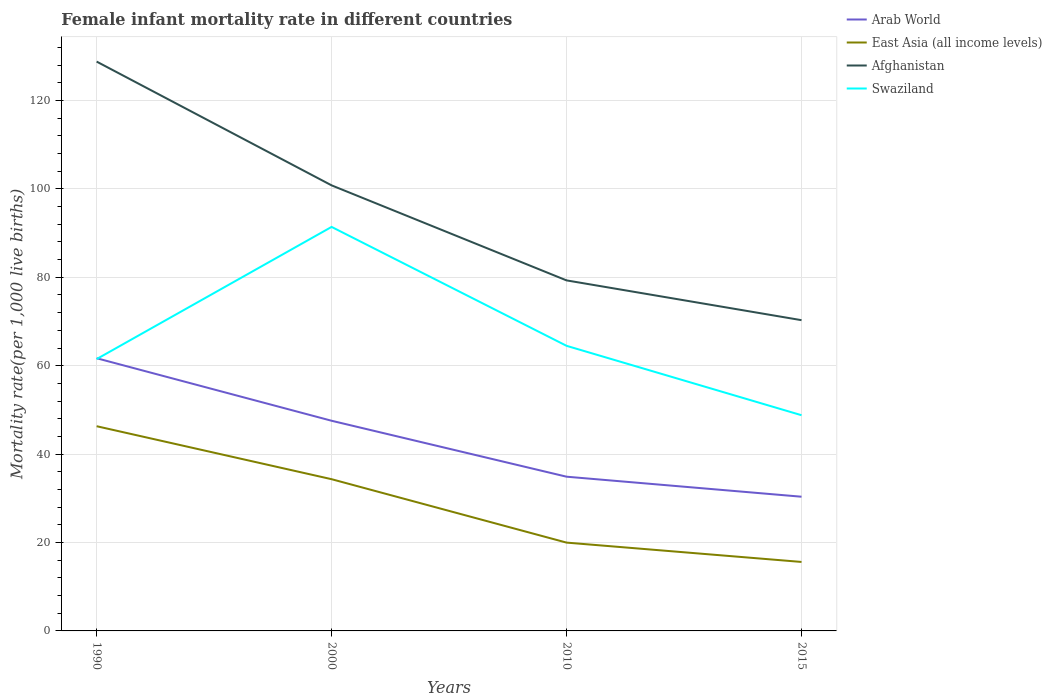How many different coloured lines are there?
Provide a short and direct response. 4. Is the number of lines equal to the number of legend labels?
Give a very brief answer. Yes. Across all years, what is the maximum female infant mortality rate in East Asia (all income levels)?
Give a very brief answer. 15.6. In which year was the female infant mortality rate in Afghanistan maximum?
Keep it short and to the point. 2015. What is the total female infant mortality rate in East Asia (all income levels) in the graph?
Your answer should be compact. 14.35. What is the difference between the highest and the second highest female infant mortality rate in East Asia (all income levels)?
Offer a very short reply. 30.71. What is the difference between two consecutive major ticks on the Y-axis?
Make the answer very short. 20. Are the values on the major ticks of Y-axis written in scientific E-notation?
Provide a succinct answer. No. Does the graph contain any zero values?
Your response must be concise. No. How many legend labels are there?
Provide a short and direct response. 4. What is the title of the graph?
Make the answer very short. Female infant mortality rate in different countries. What is the label or title of the X-axis?
Provide a succinct answer. Years. What is the label or title of the Y-axis?
Offer a very short reply. Mortality rate(per 1,0 live births). What is the Mortality rate(per 1,000 live births) of Arab World in 1990?
Ensure brevity in your answer.  61.69. What is the Mortality rate(per 1,000 live births) of East Asia (all income levels) in 1990?
Make the answer very short. 46.31. What is the Mortality rate(per 1,000 live births) in Afghanistan in 1990?
Your answer should be compact. 128.8. What is the Mortality rate(per 1,000 live births) in Swaziland in 1990?
Provide a short and direct response. 61.5. What is the Mortality rate(per 1,000 live births) of Arab World in 2000?
Provide a short and direct response. 47.55. What is the Mortality rate(per 1,000 live births) of East Asia (all income levels) in 2000?
Your answer should be compact. 34.33. What is the Mortality rate(per 1,000 live births) of Afghanistan in 2000?
Give a very brief answer. 100.8. What is the Mortality rate(per 1,000 live births) in Swaziland in 2000?
Ensure brevity in your answer.  91.4. What is the Mortality rate(per 1,000 live births) in Arab World in 2010?
Offer a terse response. 34.89. What is the Mortality rate(per 1,000 live births) in East Asia (all income levels) in 2010?
Provide a succinct answer. 19.98. What is the Mortality rate(per 1,000 live births) of Afghanistan in 2010?
Your response must be concise. 79.3. What is the Mortality rate(per 1,000 live births) of Swaziland in 2010?
Offer a terse response. 64.5. What is the Mortality rate(per 1,000 live births) of Arab World in 2015?
Offer a terse response. 30.36. What is the Mortality rate(per 1,000 live births) of East Asia (all income levels) in 2015?
Your answer should be compact. 15.6. What is the Mortality rate(per 1,000 live births) of Afghanistan in 2015?
Your answer should be compact. 70.3. What is the Mortality rate(per 1,000 live births) in Swaziland in 2015?
Offer a very short reply. 48.8. Across all years, what is the maximum Mortality rate(per 1,000 live births) of Arab World?
Ensure brevity in your answer.  61.69. Across all years, what is the maximum Mortality rate(per 1,000 live births) in East Asia (all income levels)?
Ensure brevity in your answer.  46.31. Across all years, what is the maximum Mortality rate(per 1,000 live births) in Afghanistan?
Give a very brief answer. 128.8. Across all years, what is the maximum Mortality rate(per 1,000 live births) of Swaziland?
Provide a short and direct response. 91.4. Across all years, what is the minimum Mortality rate(per 1,000 live births) of Arab World?
Offer a terse response. 30.36. Across all years, what is the minimum Mortality rate(per 1,000 live births) in East Asia (all income levels)?
Keep it short and to the point. 15.6. Across all years, what is the minimum Mortality rate(per 1,000 live births) of Afghanistan?
Offer a very short reply. 70.3. Across all years, what is the minimum Mortality rate(per 1,000 live births) in Swaziland?
Give a very brief answer. 48.8. What is the total Mortality rate(per 1,000 live births) of Arab World in the graph?
Provide a short and direct response. 174.49. What is the total Mortality rate(per 1,000 live births) of East Asia (all income levels) in the graph?
Your answer should be compact. 116.22. What is the total Mortality rate(per 1,000 live births) in Afghanistan in the graph?
Offer a terse response. 379.2. What is the total Mortality rate(per 1,000 live births) in Swaziland in the graph?
Your answer should be compact. 266.2. What is the difference between the Mortality rate(per 1,000 live births) of Arab World in 1990 and that in 2000?
Your answer should be very brief. 14.15. What is the difference between the Mortality rate(per 1,000 live births) of East Asia (all income levels) in 1990 and that in 2000?
Your response must be concise. 11.99. What is the difference between the Mortality rate(per 1,000 live births) in Afghanistan in 1990 and that in 2000?
Provide a succinct answer. 28. What is the difference between the Mortality rate(per 1,000 live births) of Swaziland in 1990 and that in 2000?
Give a very brief answer. -29.9. What is the difference between the Mortality rate(per 1,000 live births) in Arab World in 1990 and that in 2010?
Provide a short and direct response. 26.8. What is the difference between the Mortality rate(per 1,000 live births) of East Asia (all income levels) in 1990 and that in 2010?
Make the answer very short. 26.33. What is the difference between the Mortality rate(per 1,000 live births) of Afghanistan in 1990 and that in 2010?
Keep it short and to the point. 49.5. What is the difference between the Mortality rate(per 1,000 live births) of Arab World in 1990 and that in 2015?
Provide a short and direct response. 31.33. What is the difference between the Mortality rate(per 1,000 live births) of East Asia (all income levels) in 1990 and that in 2015?
Provide a succinct answer. 30.71. What is the difference between the Mortality rate(per 1,000 live births) of Afghanistan in 1990 and that in 2015?
Your answer should be very brief. 58.5. What is the difference between the Mortality rate(per 1,000 live births) in Arab World in 2000 and that in 2010?
Give a very brief answer. 12.65. What is the difference between the Mortality rate(per 1,000 live births) of East Asia (all income levels) in 2000 and that in 2010?
Make the answer very short. 14.35. What is the difference between the Mortality rate(per 1,000 live births) in Swaziland in 2000 and that in 2010?
Keep it short and to the point. 26.9. What is the difference between the Mortality rate(per 1,000 live births) of Arab World in 2000 and that in 2015?
Make the answer very short. 17.18. What is the difference between the Mortality rate(per 1,000 live births) of East Asia (all income levels) in 2000 and that in 2015?
Your answer should be compact. 18.72. What is the difference between the Mortality rate(per 1,000 live births) in Afghanistan in 2000 and that in 2015?
Make the answer very short. 30.5. What is the difference between the Mortality rate(per 1,000 live births) in Swaziland in 2000 and that in 2015?
Your response must be concise. 42.6. What is the difference between the Mortality rate(per 1,000 live births) of Arab World in 2010 and that in 2015?
Give a very brief answer. 4.53. What is the difference between the Mortality rate(per 1,000 live births) in East Asia (all income levels) in 2010 and that in 2015?
Provide a short and direct response. 4.37. What is the difference between the Mortality rate(per 1,000 live births) of Arab World in 1990 and the Mortality rate(per 1,000 live births) of East Asia (all income levels) in 2000?
Make the answer very short. 27.37. What is the difference between the Mortality rate(per 1,000 live births) of Arab World in 1990 and the Mortality rate(per 1,000 live births) of Afghanistan in 2000?
Provide a short and direct response. -39.11. What is the difference between the Mortality rate(per 1,000 live births) in Arab World in 1990 and the Mortality rate(per 1,000 live births) in Swaziland in 2000?
Your answer should be compact. -29.71. What is the difference between the Mortality rate(per 1,000 live births) in East Asia (all income levels) in 1990 and the Mortality rate(per 1,000 live births) in Afghanistan in 2000?
Your answer should be very brief. -54.49. What is the difference between the Mortality rate(per 1,000 live births) in East Asia (all income levels) in 1990 and the Mortality rate(per 1,000 live births) in Swaziland in 2000?
Give a very brief answer. -45.09. What is the difference between the Mortality rate(per 1,000 live births) of Afghanistan in 1990 and the Mortality rate(per 1,000 live births) of Swaziland in 2000?
Ensure brevity in your answer.  37.4. What is the difference between the Mortality rate(per 1,000 live births) of Arab World in 1990 and the Mortality rate(per 1,000 live births) of East Asia (all income levels) in 2010?
Keep it short and to the point. 41.71. What is the difference between the Mortality rate(per 1,000 live births) of Arab World in 1990 and the Mortality rate(per 1,000 live births) of Afghanistan in 2010?
Your response must be concise. -17.61. What is the difference between the Mortality rate(per 1,000 live births) in Arab World in 1990 and the Mortality rate(per 1,000 live births) in Swaziland in 2010?
Offer a terse response. -2.81. What is the difference between the Mortality rate(per 1,000 live births) in East Asia (all income levels) in 1990 and the Mortality rate(per 1,000 live births) in Afghanistan in 2010?
Your response must be concise. -32.99. What is the difference between the Mortality rate(per 1,000 live births) of East Asia (all income levels) in 1990 and the Mortality rate(per 1,000 live births) of Swaziland in 2010?
Give a very brief answer. -18.19. What is the difference between the Mortality rate(per 1,000 live births) in Afghanistan in 1990 and the Mortality rate(per 1,000 live births) in Swaziland in 2010?
Your answer should be very brief. 64.3. What is the difference between the Mortality rate(per 1,000 live births) of Arab World in 1990 and the Mortality rate(per 1,000 live births) of East Asia (all income levels) in 2015?
Ensure brevity in your answer.  46.09. What is the difference between the Mortality rate(per 1,000 live births) in Arab World in 1990 and the Mortality rate(per 1,000 live births) in Afghanistan in 2015?
Your answer should be very brief. -8.61. What is the difference between the Mortality rate(per 1,000 live births) of Arab World in 1990 and the Mortality rate(per 1,000 live births) of Swaziland in 2015?
Offer a very short reply. 12.89. What is the difference between the Mortality rate(per 1,000 live births) in East Asia (all income levels) in 1990 and the Mortality rate(per 1,000 live births) in Afghanistan in 2015?
Your answer should be compact. -23.99. What is the difference between the Mortality rate(per 1,000 live births) of East Asia (all income levels) in 1990 and the Mortality rate(per 1,000 live births) of Swaziland in 2015?
Provide a succinct answer. -2.49. What is the difference between the Mortality rate(per 1,000 live births) of Arab World in 2000 and the Mortality rate(per 1,000 live births) of East Asia (all income levels) in 2010?
Give a very brief answer. 27.57. What is the difference between the Mortality rate(per 1,000 live births) in Arab World in 2000 and the Mortality rate(per 1,000 live births) in Afghanistan in 2010?
Keep it short and to the point. -31.75. What is the difference between the Mortality rate(per 1,000 live births) in Arab World in 2000 and the Mortality rate(per 1,000 live births) in Swaziland in 2010?
Give a very brief answer. -16.95. What is the difference between the Mortality rate(per 1,000 live births) in East Asia (all income levels) in 2000 and the Mortality rate(per 1,000 live births) in Afghanistan in 2010?
Provide a succinct answer. -44.97. What is the difference between the Mortality rate(per 1,000 live births) of East Asia (all income levels) in 2000 and the Mortality rate(per 1,000 live births) of Swaziland in 2010?
Your answer should be very brief. -30.17. What is the difference between the Mortality rate(per 1,000 live births) of Afghanistan in 2000 and the Mortality rate(per 1,000 live births) of Swaziland in 2010?
Your answer should be compact. 36.3. What is the difference between the Mortality rate(per 1,000 live births) in Arab World in 2000 and the Mortality rate(per 1,000 live births) in East Asia (all income levels) in 2015?
Your answer should be very brief. 31.94. What is the difference between the Mortality rate(per 1,000 live births) of Arab World in 2000 and the Mortality rate(per 1,000 live births) of Afghanistan in 2015?
Give a very brief answer. -22.75. What is the difference between the Mortality rate(per 1,000 live births) in Arab World in 2000 and the Mortality rate(per 1,000 live births) in Swaziland in 2015?
Provide a short and direct response. -1.25. What is the difference between the Mortality rate(per 1,000 live births) of East Asia (all income levels) in 2000 and the Mortality rate(per 1,000 live births) of Afghanistan in 2015?
Your answer should be very brief. -35.97. What is the difference between the Mortality rate(per 1,000 live births) of East Asia (all income levels) in 2000 and the Mortality rate(per 1,000 live births) of Swaziland in 2015?
Your answer should be very brief. -14.47. What is the difference between the Mortality rate(per 1,000 live births) of Arab World in 2010 and the Mortality rate(per 1,000 live births) of East Asia (all income levels) in 2015?
Give a very brief answer. 19.29. What is the difference between the Mortality rate(per 1,000 live births) in Arab World in 2010 and the Mortality rate(per 1,000 live births) in Afghanistan in 2015?
Your answer should be very brief. -35.41. What is the difference between the Mortality rate(per 1,000 live births) of Arab World in 2010 and the Mortality rate(per 1,000 live births) of Swaziland in 2015?
Offer a terse response. -13.91. What is the difference between the Mortality rate(per 1,000 live births) in East Asia (all income levels) in 2010 and the Mortality rate(per 1,000 live births) in Afghanistan in 2015?
Provide a succinct answer. -50.32. What is the difference between the Mortality rate(per 1,000 live births) in East Asia (all income levels) in 2010 and the Mortality rate(per 1,000 live births) in Swaziland in 2015?
Your response must be concise. -28.82. What is the difference between the Mortality rate(per 1,000 live births) of Afghanistan in 2010 and the Mortality rate(per 1,000 live births) of Swaziland in 2015?
Offer a terse response. 30.5. What is the average Mortality rate(per 1,000 live births) in Arab World per year?
Give a very brief answer. 43.62. What is the average Mortality rate(per 1,000 live births) of East Asia (all income levels) per year?
Your answer should be very brief. 29.06. What is the average Mortality rate(per 1,000 live births) of Afghanistan per year?
Your answer should be compact. 94.8. What is the average Mortality rate(per 1,000 live births) of Swaziland per year?
Make the answer very short. 66.55. In the year 1990, what is the difference between the Mortality rate(per 1,000 live births) of Arab World and Mortality rate(per 1,000 live births) of East Asia (all income levels)?
Offer a terse response. 15.38. In the year 1990, what is the difference between the Mortality rate(per 1,000 live births) in Arab World and Mortality rate(per 1,000 live births) in Afghanistan?
Provide a short and direct response. -67.11. In the year 1990, what is the difference between the Mortality rate(per 1,000 live births) in Arab World and Mortality rate(per 1,000 live births) in Swaziland?
Make the answer very short. 0.19. In the year 1990, what is the difference between the Mortality rate(per 1,000 live births) in East Asia (all income levels) and Mortality rate(per 1,000 live births) in Afghanistan?
Provide a succinct answer. -82.49. In the year 1990, what is the difference between the Mortality rate(per 1,000 live births) of East Asia (all income levels) and Mortality rate(per 1,000 live births) of Swaziland?
Your response must be concise. -15.19. In the year 1990, what is the difference between the Mortality rate(per 1,000 live births) in Afghanistan and Mortality rate(per 1,000 live births) in Swaziland?
Offer a terse response. 67.3. In the year 2000, what is the difference between the Mortality rate(per 1,000 live births) of Arab World and Mortality rate(per 1,000 live births) of East Asia (all income levels)?
Offer a terse response. 13.22. In the year 2000, what is the difference between the Mortality rate(per 1,000 live births) in Arab World and Mortality rate(per 1,000 live births) in Afghanistan?
Give a very brief answer. -53.25. In the year 2000, what is the difference between the Mortality rate(per 1,000 live births) in Arab World and Mortality rate(per 1,000 live births) in Swaziland?
Make the answer very short. -43.85. In the year 2000, what is the difference between the Mortality rate(per 1,000 live births) of East Asia (all income levels) and Mortality rate(per 1,000 live births) of Afghanistan?
Ensure brevity in your answer.  -66.47. In the year 2000, what is the difference between the Mortality rate(per 1,000 live births) in East Asia (all income levels) and Mortality rate(per 1,000 live births) in Swaziland?
Provide a succinct answer. -57.07. In the year 2000, what is the difference between the Mortality rate(per 1,000 live births) in Afghanistan and Mortality rate(per 1,000 live births) in Swaziland?
Keep it short and to the point. 9.4. In the year 2010, what is the difference between the Mortality rate(per 1,000 live births) of Arab World and Mortality rate(per 1,000 live births) of East Asia (all income levels)?
Provide a short and direct response. 14.91. In the year 2010, what is the difference between the Mortality rate(per 1,000 live births) in Arab World and Mortality rate(per 1,000 live births) in Afghanistan?
Give a very brief answer. -44.41. In the year 2010, what is the difference between the Mortality rate(per 1,000 live births) in Arab World and Mortality rate(per 1,000 live births) in Swaziland?
Ensure brevity in your answer.  -29.61. In the year 2010, what is the difference between the Mortality rate(per 1,000 live births) in East Asia (all income levels) and Mortality rate(per 1,000 live births) in Afghanistan?
Offer a very short reply. -59.32. In the year 2010, what is the difference between the Mortality rate(per 1,000 live births) in East Asia (all income levels) and Mortality rate(per 1,000 live births) in Swaziland?
Give a very brief answer. -44.52. In the year 2010, what is the difference between the Mortality rate(per 1,000 live births) of Afghanistan and Mortality rate(per 1,000 live births) of Swaziland?
Offer a terse response. 14.8. In the year 2015, what is the difference between the Mortality rate(per 1,000 live births) in Arab World and Mortality rate(per 1,000 live births) in East Asia (all income levels)?
Provide a short and direct response. 14.76. In the year 2015, what is the difference between the Mortality rate(per 1,000 live births) in Arab World and Mortality rate(per 1,000 live births) in Afghanistan?
Your answer should be very brief. -39.94. In the year 2015, what is the difference between the Mortality rate(per 1,000 live births) in Arab World and Mortality rate(per 1,000 live births) in Swaziland?
Your response must be concise. -18.44. In the year 2015, what is the difference between the Mortality rate(per 1,000 live births) of East Asia (all income levels) and Mortality rate(per 1,000 live births) of Afghanistan?
Offer a terse response. -54.7. In the year 2015, what is the difference between the Mortality rate(per 1,000 live births) of East Asia (all income levels) and Mortality rate(per 1,000 live births) of Swaziland?
Give a very brief answer. -33.2. What is the ratio of the Mortality rate(per 1,000 live births) of Arab World in 1990 to that in 2000?
Your answer should be compact. 1.3. What is the ratio of the Mortality rate(per 1,000 live births) of East Asia (all income levels) in 1990 to that in 2000?
Provide a succinct answer. 1.35. What is the ratio of the Mortality rate(per 1,000 live births) in Afghanistan in 1990 to that in 2000?
Your answer should be very brief. 1.28. What is the ratio of the Mortality rate(per 1,000 live births) of Swaziland in 1990 to that in 2000?
Offer a terse response. 0.67. What is the ratio of the Mortality rate(per 1,000 live births) in Arab World in 1990 to that in 2010?
Ensure brevity in your answer.  1.77. What is the ratio of the Mortality rate(per 1,000 live births) of East Asia (all income levels) in 1990 to that in 2010?
Your answer should be compact. 2.32. What is the ratio of the Mortality rate(per 1,000 live births) in Afghanistan in 1990 to that in 2010?
Make the answer very short. 1.62. What is the ratio of the Mortality rate(per 1,000 live births) in Swaziland in 1990 to that in 2010?
Make the answer very short. 0.95. What is the ratio of the Mortality rate(per 1,000 live births) of Arab World in 1990 to that in 2015?
Provide a short and direct response. 2.03. What is the ratio of the Mortality rate(per 1,000 live births) in East Asia (all income levels) in 1990 to that in 2015?
Make the answer very short. 2.97. What is the ratio of the Mortality rate(per 1,000 live births) of Afghanistan in 1990 to that in 2015?
Make the answer very short. 1.83. What is the ratio of the Mortality rate(per 1,000 live births) of Swaziland in 1990 to that in 2015?
Keep it short and to the point. 1.26. What is the ratio of the Mortality rate(per 1,000 live births) in Arab World in 2000 to that in 2010?
Make the answer very short. 1.36. What is the ratio of the Mortality rate(per 1,000 live births) in East Asia (all income levels) in 2000 to that in 2010?
Ensure brevity in your answer.  1.72. What is the ratio of the Mortality rate(per 1,000 live births) in Afghanistan in 2000 to that in 2010?
Your response must be concise. 1.27. What is the ratio of the Mortality rate(per 1,000 live births) of Swaziland in 2000 to that in 2010?
Offer a very short reply. 1.42. What is the ratio of the Mortality rate(per 1,000 live births) of Arab World in 2000 to that in 2015?
Offer a very short reply. 1.57. What is the ratio of the Mortality rate(per 1,000 live births) of East Asia (all income levels) in 2000 to that in 2015?
Provide a short and direct response. 2.2. What is the ratio of the Mortality rate(per 1,000 live births) of Afghanistan in 2000 to that in 2015?
Provide a short and direct response. 1.43. What is the ratio of the Mortality rate(per 1,000 live births) of Swaziland in 2000 to that in 2015?
Provide a short and direct response. 1.87. What is the ratio of the Mortality rate(per 1,000 live births) of Arab World in 2010 to that in 2015?
Offer a very short reply. 1.15. What is the ratio of the Mortality rate(per 1,000 live births) of East Asia (all income levels) in 2010 to that in 2015?
Provide a short and direct response. 1.28. What is the ratio of the Mortality rate(per 1,000 live births) in Afghanistan in 2010 to that in 2015?
Your answer should be compact. 1.13. What is the ratio of the Mortality rate(per 1,000 live births) of Swaziland in 2010 to that in 2015?
Ensure brevity in your answer.  1.32. What is the difference between the highest and the second highest Mortality rate(per 1,000 live births) in Arab World?
Offer a very short reply. 14.15. What is the difference between the highest and the second highest Mortality rate(per 1,000 live births) in East Asia (all income levels)?
Your answer should be very brief. 11.99. What is the difference between the highest and the second highest Mortality rate(per 1,000 live births) of Afghanistan?
Make the answer very short. 28. What is the difference between the highest and the second highest Mortality rate(per 1,000 live births) of Swaziland?
Your answer should be compact. 26.9. What is the difference between the highest and the lowest Mortality rate(per 1,000 live births) in Arab World?
Offer a very short reply. 31.33. What is the difference between the highest and the lowest Mortality rate(per 1,000 live births) in East Asia (all income levels)?
Offer a terse response. 30.71. What is the difference between the highest and the lowest Mortality rate(per 1,000 live births) in Afghanistan?
Keep it short and to the point. 58.5. What is the difference between the highest and the lowest Mortality rate(per 1,000 live births) of Swaziland?
Your answer should be compact. 42.6. 